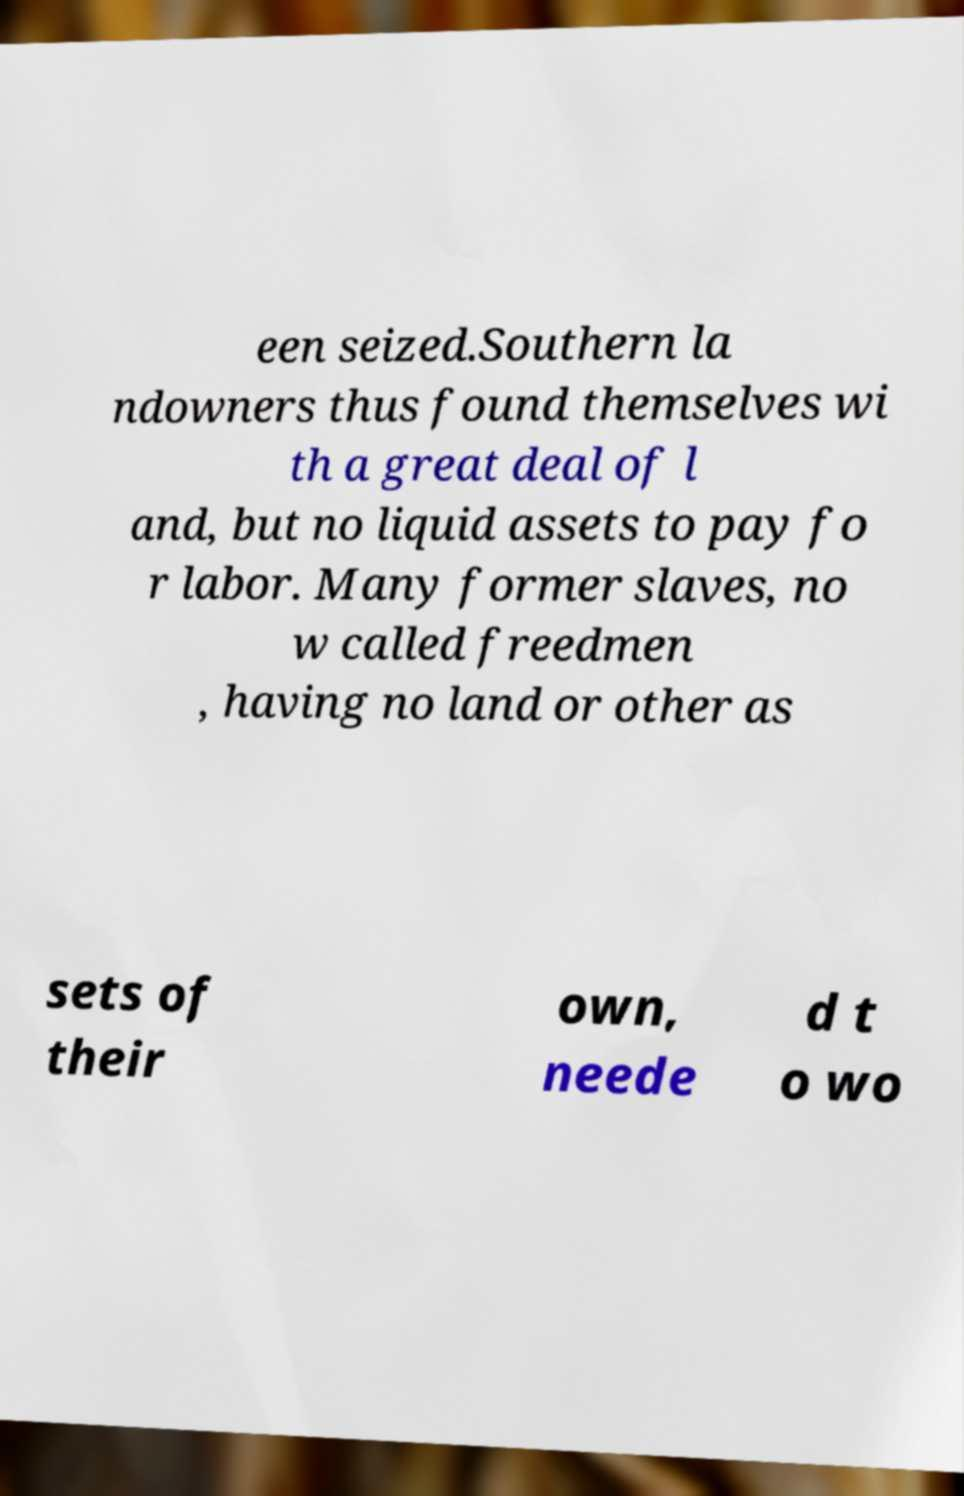I need the written content from this picture converted into text. Can you do that? een seized.Southern la ndowners thus found themselves wi th a great deal of l and, but no liquid assets to pay fo r labor. Many former slaves, no w called freedmen , having no land or other as sets of their own, neede d t o wo 